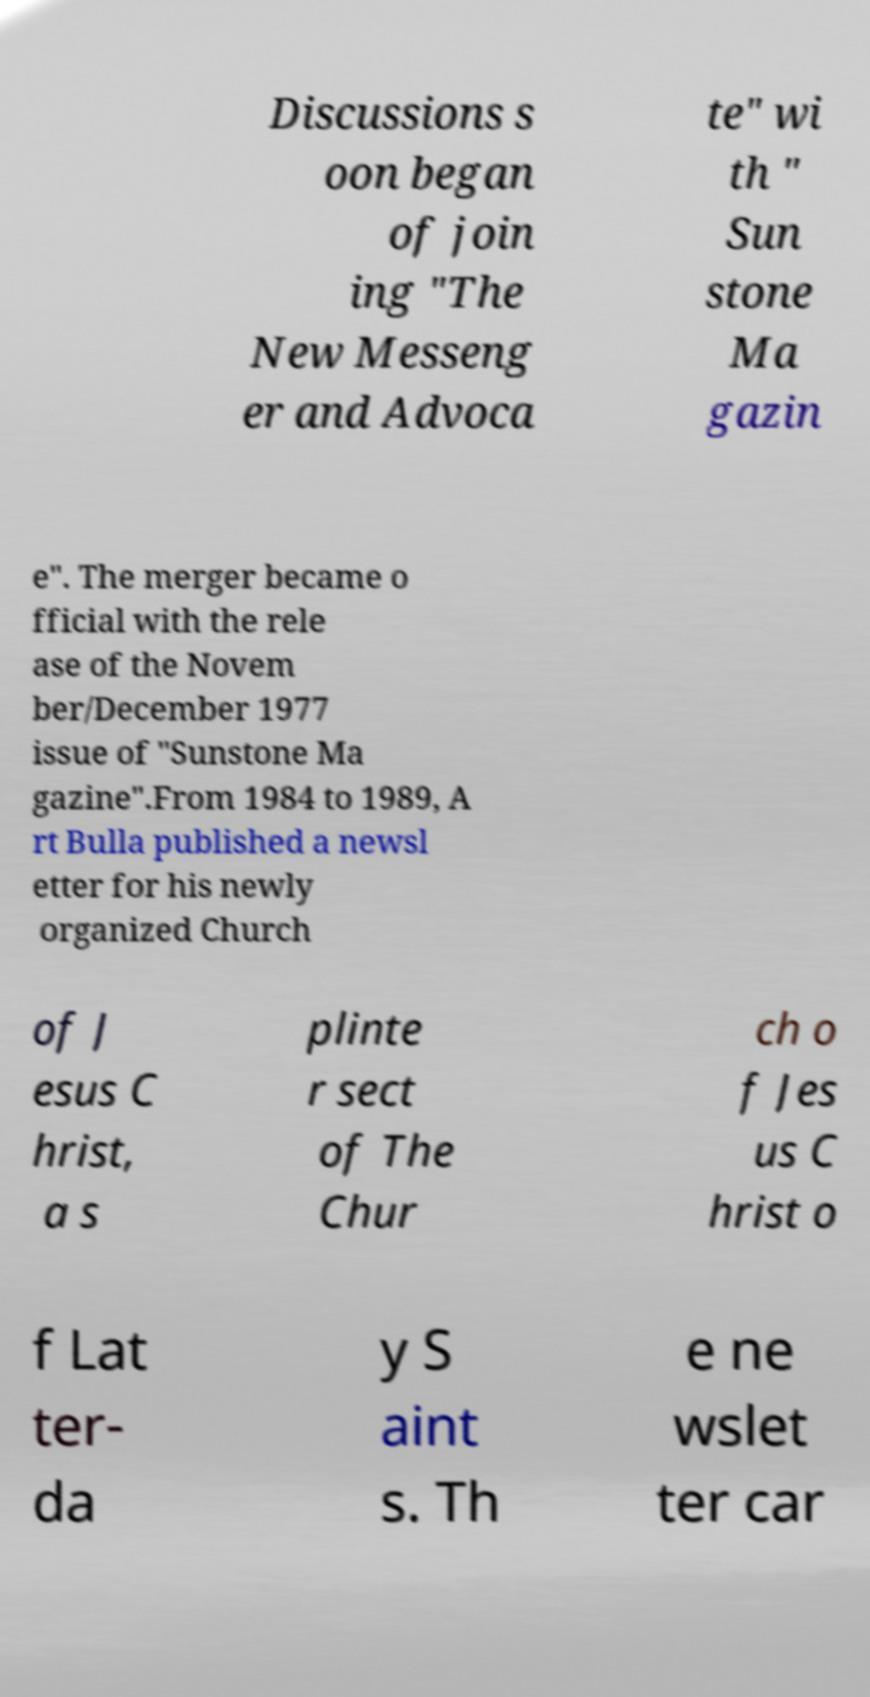Please identify and transcribe the text found in this image. Discussions s oon began of join ing "The New Messeng er and Advoca te" wi th " Sun stone Ma gazin e". The merger became o fficial with the rele ase of the Novem ber/December 1977 issue of "Sunstone Ma gazine".From 1984 to 1989, A rt Bulla published a newsl etter for his newly organized Church of J esus C hrist, a s plinte r sect of The Chur ch o f Jes us C hrist o f Lat ter- da y S aint s. Th e ne wslet ter car 